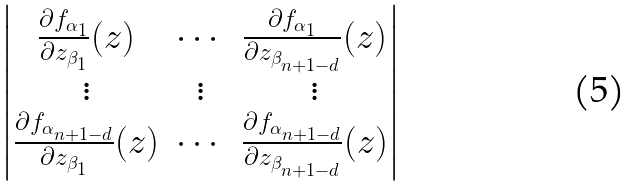Convert formula to latex. <formula><loc_0><loc_0><loc_500><loc_500>\begin{vmatrix} \frac { \partial f _ { \alpha _ { 1 } } } { \partial z _ { \beta _ { 1 } } } ( z ) & \cdots & \frac { \partial f _ { \alpha _ { 1 } } } { \partial z _ { \beta _ { n + 1 - d } } } ( z ) \\ \vdots & \vdots & \vdots \\ \frac { \partial f _ { \alpha _ { n + 1 - d } } } { \partial z _ { \beta _ { 1 } } } ( z ) & \cdots & \frac { \partial f _ { \alpha _ { n + 1 - d } } } { \partial z _ { \beta _ { n + 1 - d } } } ( z ) \end{vmatrix}</formula> 